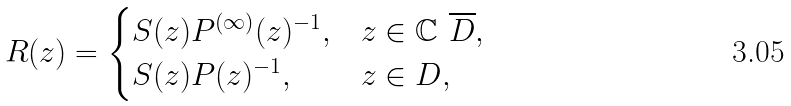Convert formula to latex. <formula><loc_0><loc_0><loc_500><loc_500>R ( z ) = \begin{cases} S ( z ) P ^ { ( \infty ) } ( z ) ^ { - 1 } , & z \in \mathbb { C } \ \overline { D } , \\ S ( z ) P ( z ) ^ { - 1 } , & z \in D , \end{cases}</formula> 